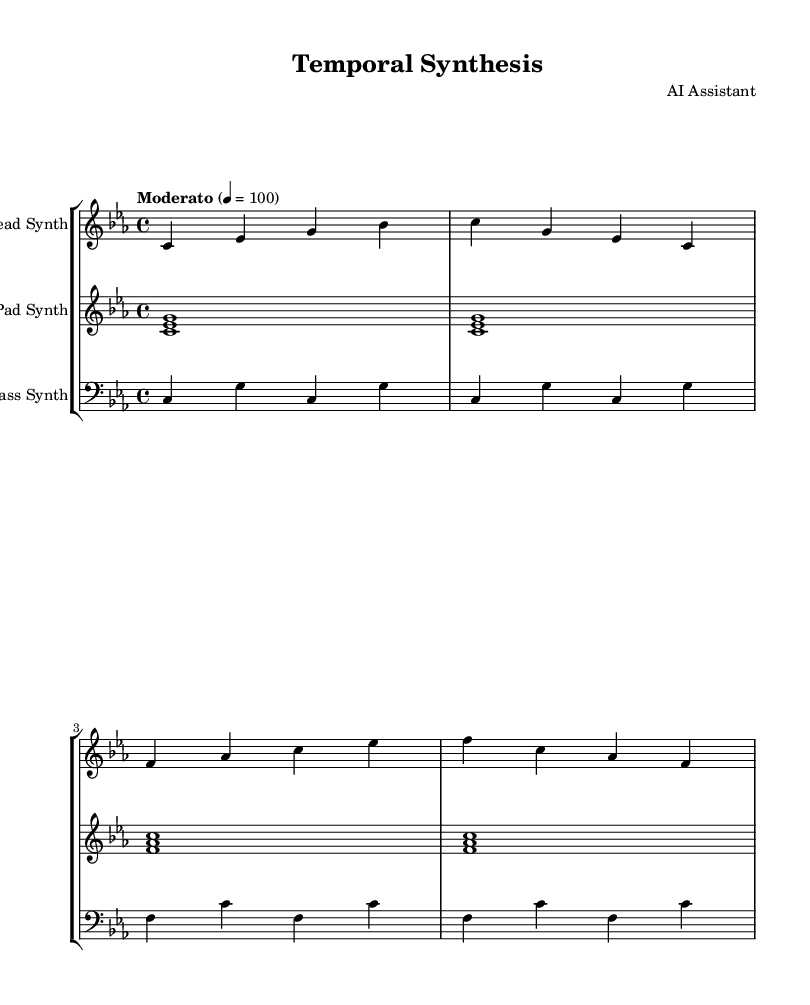What is the key signature of this music? The key signature is C minor, which has three flats (B flat, E flat, and A flat). This can be identified by looking at the beginning of the staff, where the flats are placed.
Answer: C minor What is the time signature of this music? The time signature is 4/4, indicating there are four beats per measure and the quarter note gets one beat. This is found at the beginning of the score, right after the key signature.
Answer: 4/4 What is the tempo marking of this music? The tempo marking indicates "Moderato" at a speed of 100 beats per minute. This is noted in the tempo indication which dictates the speed of the piece.
Answer: Moderato 100 How many measures are in the lead synth part? The lead synth part contains four measures. This can be counted by looking at the bar lines that separate each measure.
Answer: Four Which synth part plays the lowest notes in the score? The bass synth part plays the lowest notes, as indicated by its clef (bass clef) and the register of the notes used in that staff.
Answer: Bass Synth What are the first three notes of the pad synth? The first three notes of the pad synth are C, E flat, and G. This can be observed directly from the first measure of the pad synth line.
Answer: C E flat G Which instrument is primarily responsible for the melodic content in this piece? The lead synth is primarily responsible for the melodic content, as it plays the most prominent single notes that create the main melody. This is identifiable as the highest part on the staff and the use of single notes.
Answer: Lead Synth 